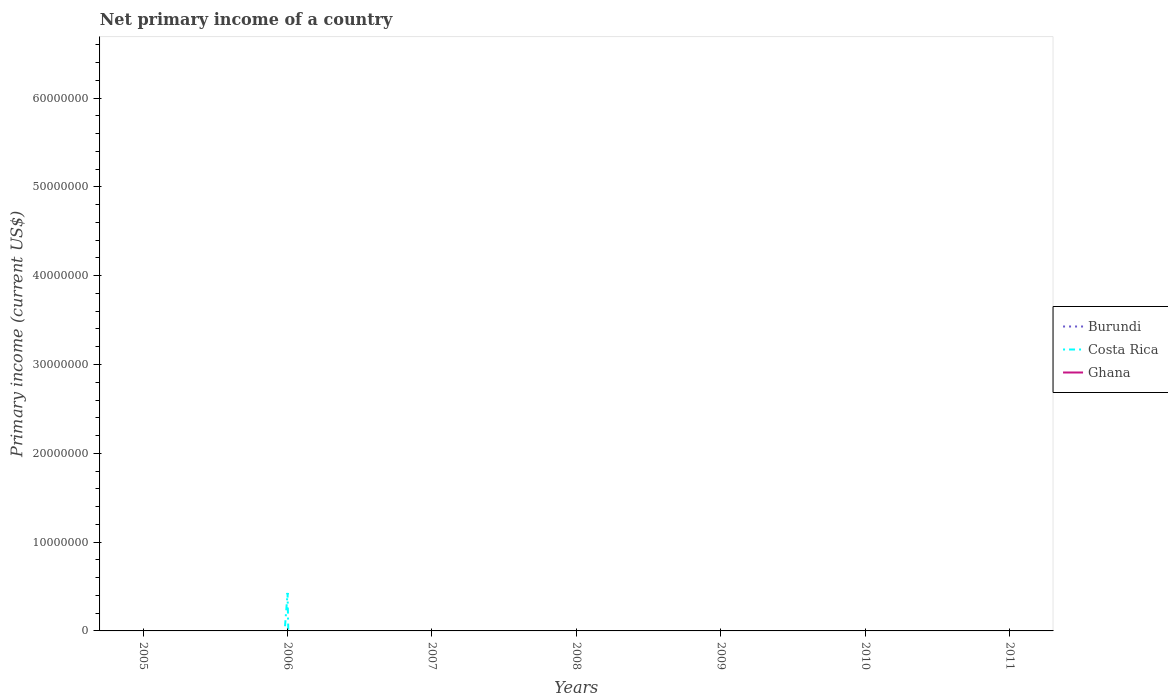Does the line corresponding to Burundi intersect with the line corresponding to Ghana?
Ensure brevity in your answer.  No. Is the number of lines equal to the number of legend labels?
Make the answer very short. No. Across all years, what is the maximum primary income in Costa Rica?
Offer a very short reply. 0. What is the difference between the highest and the second highest primary income in Costa Rica?
Provide a succinct answer. 4.28e+06. What is the difference between the highest and the lowest primary income in Costa Rica?
Offer a terse response. 1. Is the primary income in Ghana strictly greater than the primary income in Costa Rica over the years?
Offer a very short reply. No. How many lines are there?
Offer a terse response. 1. What is the difference between two consecutive major ticks on the Y-axis?
Offer a terse response. 1.00e+07. Does the graph contain any zero values?
Your response must be concise. Yes. Does the graph contain grids?
Keep it short and to the point. No. Where does the legend appear in the graph?
Your answer should be very brief. Center right. How many legend labels are there?
Ensure brevity in your answer.  3. How are the legend labels stacked?
Ensure brevity in your answer.  Vertical. What is the title of the graph?
Offer a terse response. Net primary income of a country. What is the label or title of the X-axis?
Keep it short and to the point. Years. What is the label or title of the Y-axis?
Your response must be concise. Primary income (current US$). What is the Primary income (current US$) of Burundi in 2005?
Your answer should be very brief. 0. What is the Primary income (current US$) of Costa Rica in 2005?
Offer a very short reply. 0. What is the Primary income (current US$) of Costa Rica in 2006?
Your answer should be very brief. 4.28e+06. What is the Primary income (current US$) of Ghana in 2006?
Keep it short and to the point. 0. What is the Primary income (current US$) in Costa Rica in 2007?
Give a very brief answer. 0. What is the Primary income (current US$) of Ghana in 2007?
Provide a short and direct response. 0. What is the Primary income (current US$) in Burundi in 2008?
Make the answer very short. 0. What is the Primary income (current US$) in Costa Rica in 2009?
Provide a succinct answer. 0. What is the Primary income (current US$) of Burundi in 2010?
Offer a terse response. 0. What is the Primary income (current US$) in Burundi in 2011?
Make the answer very short. 0. What is the Primary income (current US$) in Ghana in 2011?
Your answer should be very brief. 0. Across all years, what is the maximum Primary income (current US$) of Costa Rica?
Ensure brevity in your answer.  4.28e+06. What is the total Primary income (current US$) of Burundi in the graph?
Ensure brevity in your answer.  0. What is the total Primary income (current US$) in Costa Rica in the graph?
Your response must be concise. 4.28e+06. What is the total Primary income (current US$) of Ghana in the graph?
Provide a short and direct response. 0. What is the average Primary income (current US$) of Costa Rica per year?
Provide a short and direct response. 6.11e+05. What is the average Primary income (current US$) of Ghana per year?
Offer a terse response. 0. What is the difference between the highest and the lowest Primary income (current US$) in Costa Rica?
Your response must be concise. 4.28e+06. 